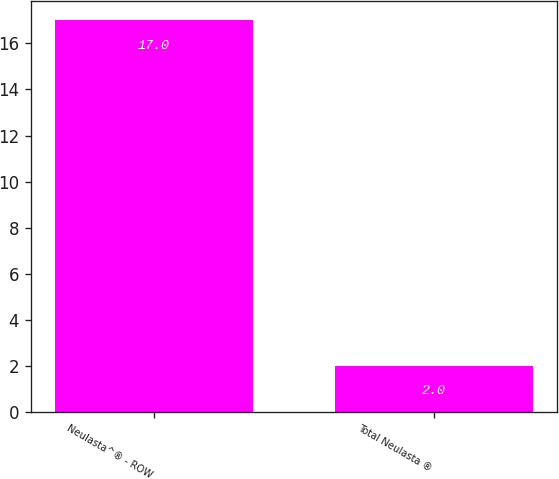Convert chart to OTSL. <chart><loc_0><loc_0><loc_500><loc_500><bar_chart><fcel>Neulasta^® - ROW<fcel>Total Neulasta ®<nl><fcel>17<fcel>2<nl></chart> 